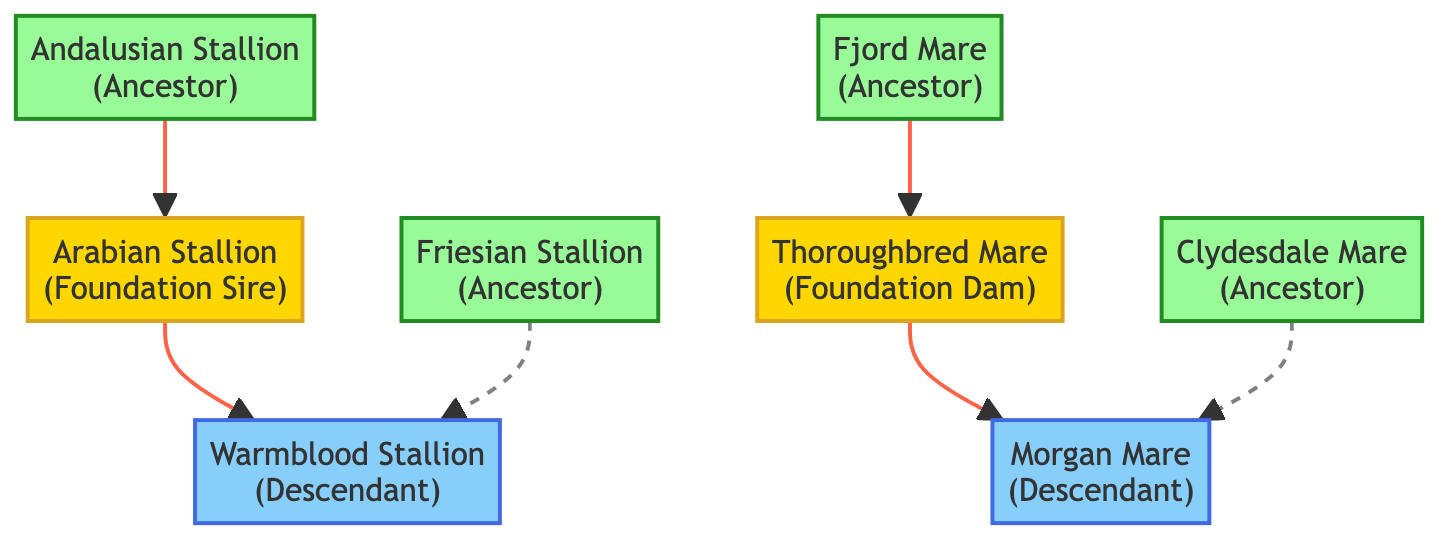What is the role of Horse1? Horse1 is labeled as the "Foundation Sire." This information is directly extracted from the node description in the diagram.
Answer: Foundation Sire How many descendants are shown in the diagram? There are two descendants depicted: Horse7 (Warmblood Stallion) and Horse8 (Morgan Mare). This counts the nodes with the role "Descendant."
Answer: 2 What relationship exists between Horse3 and Horse1? Horse3 is connected to Horse1 with a direct arrow indicating a "parent" relationship, meaning that Horse3 is the parent of Horse1.
Answer: parent Which horse is an ancestor to Horse8? Horse6 is indicated as an ancestor of Horse8, with a dashed relationship line, specifying that Horse6 has ancestral connections to Horse8.
Answer: Clydesdale Mare How many total horses are represented in the diagram? By counting all the nodes listed, there are a total of eight horses in the diagram, hence we total the node entries.
Answer: 8 What is the generation number of the Thoroughbred Mare? The Thoroughbred Mare (Horse2) is listed with a generation number of 1, as indicated in the node data.
Answer: 1 Name one horse that is a descendant of the Arabian Stallion. Horse7 (Warmblood Stallion) is the descendant of the Arabian Stallion, which can be inferred from the directed relationship in the diagram.
Answer: Warmblood Stallion What is the connection type between Horse5 and Horse7? Horse5 has a dashed connection labeled as "ancestor" to Horse7, which indicates a less direct ancestral relationship compared to direct parentage.
Answer: ancestor 